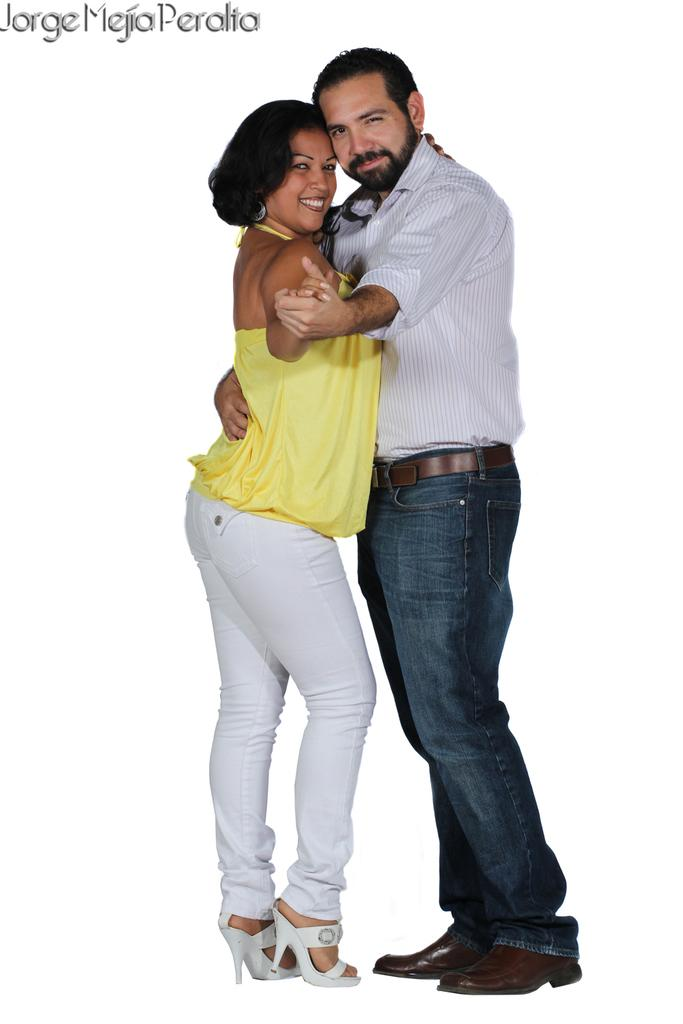Who are the people in the image? There is a couple in the image. What are the couple doing in the image? The couple is standing in a dancing position. What might be the purpose of their stance? The couple is posing for a photo. What is the color of the background in the image? The background of the image is white. What nation is the couple teaching in the image? There is no indication in the image that the couple is teaching or in a specific nation. 